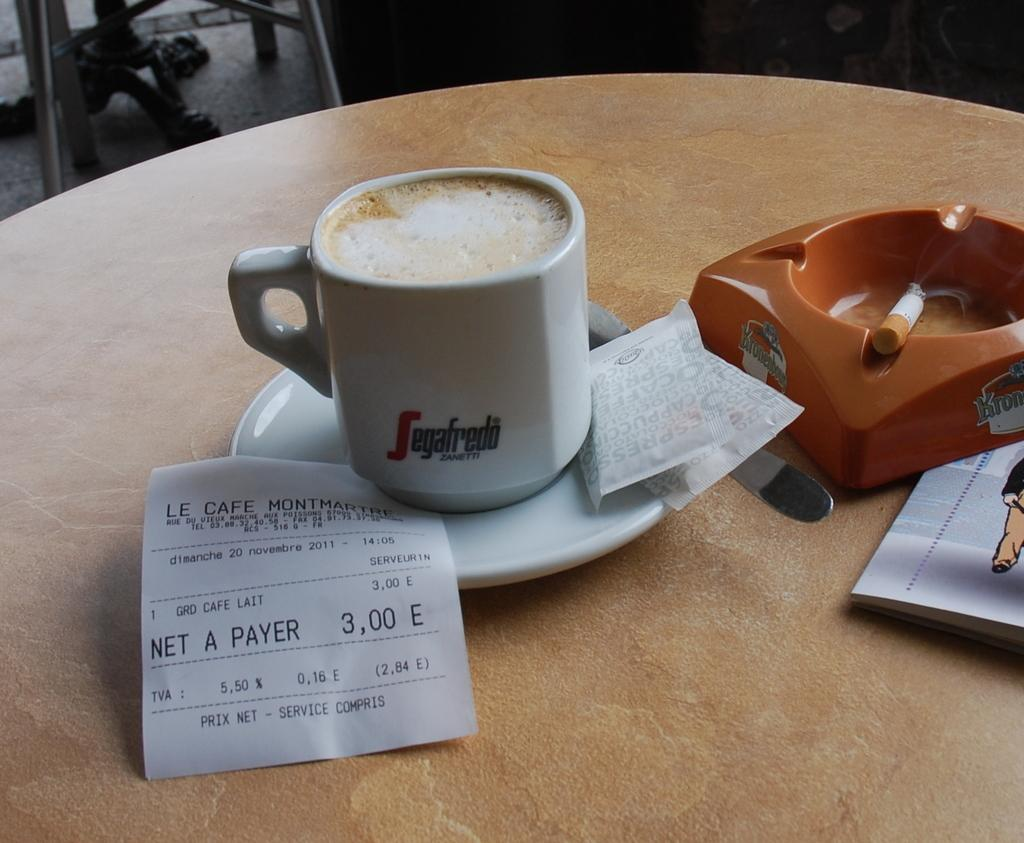Provide a one-sentence caption for the provided image. a cup of Segafredo Zanetti espresso on a table next to an ashtray. 